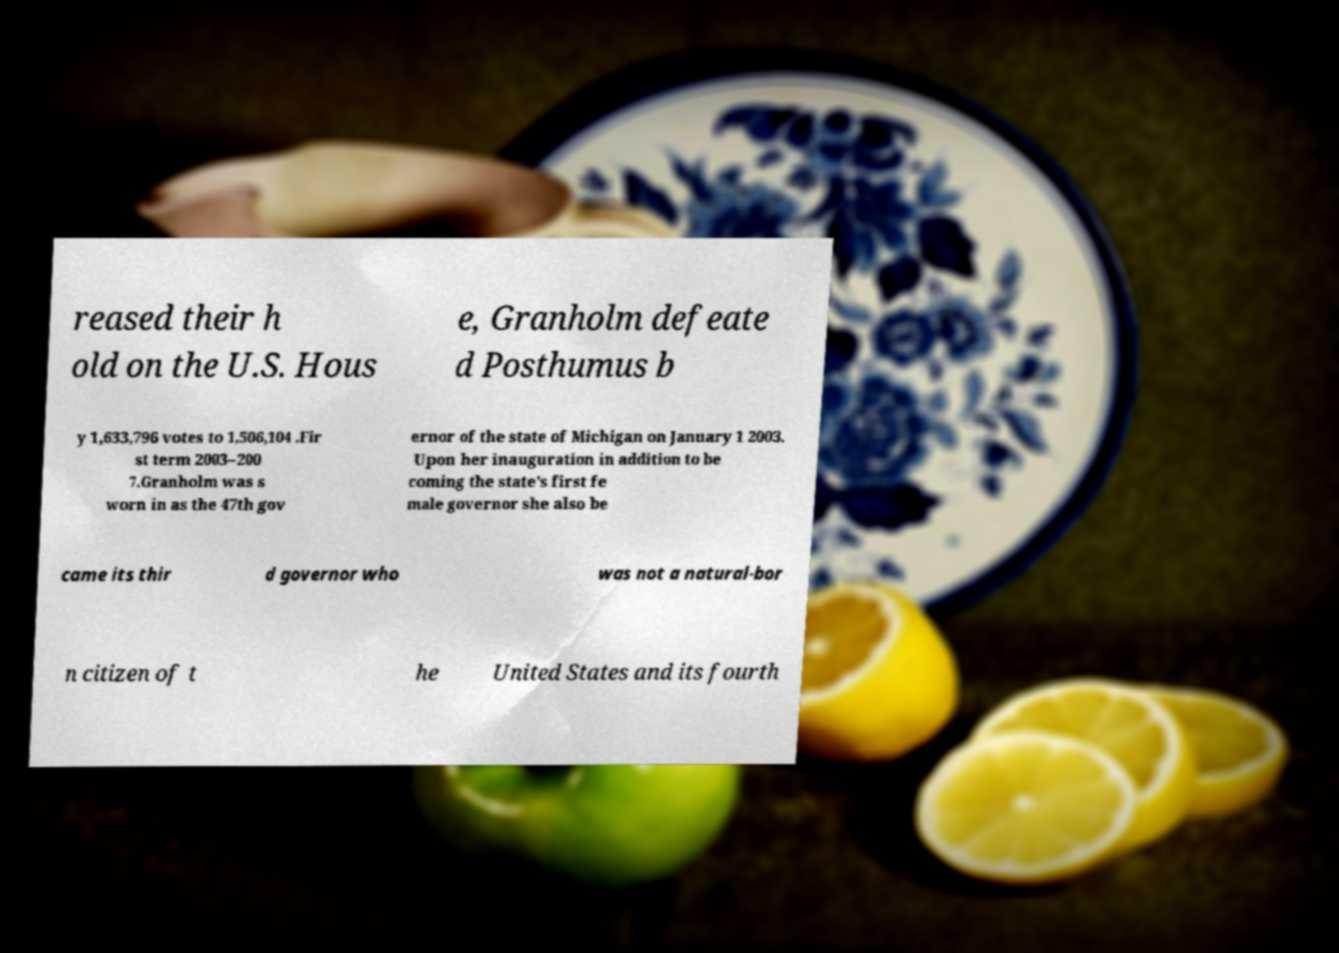Please identify and transcribe the text found in this image. reased their h old on the U.S. Hous e, Granholm defeate d Posthumus b y 1,633,796 votes to 1,506,104 .Fir st term 2003–200 7.Granholm was s worn in as the 47th gov ernor of the state of Michigan on January 1 2003. Upon her inauguration in addition to be coming the state's first fe male governor she also be came its thir d governor who was not a natural-bor n citizen of t he United States and its fourth 